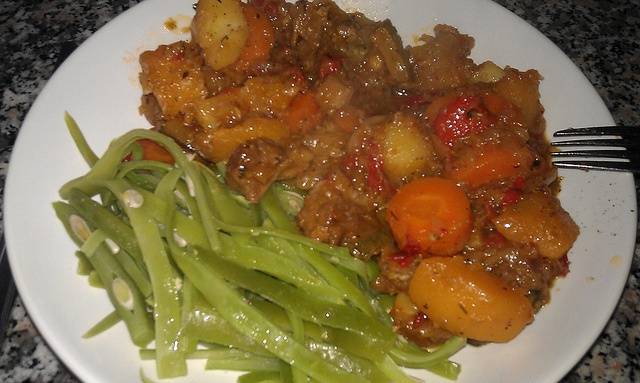Describe the objects in this image and their specific colors. I can see dining table in black, gray, and darkgray tones, carrot in black, brown, maroon, and red tones, carrot in black, red, and maroon tones, fork in black, gray, darkgray, and white tones, and carrot in black, maroon, and brown tones in this image. 